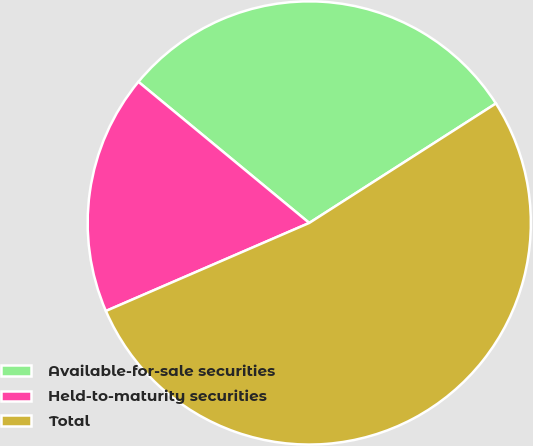Convert chart. <chart><loc_0><loc_0><loc_500><loc_500><pie_chart><fcel>Available-for-sale securities<fcel>Held-to-maturity securities<fcel>Total<nl><fcel>29.95%<fcel>17.49%<fcel>52.56%<nl></chart> 